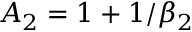<formula> <loc_0><loc_0><loc_500><loc_500>A _ { 2 } = 1 + 1 / \beta _ { 2 }</formula> 